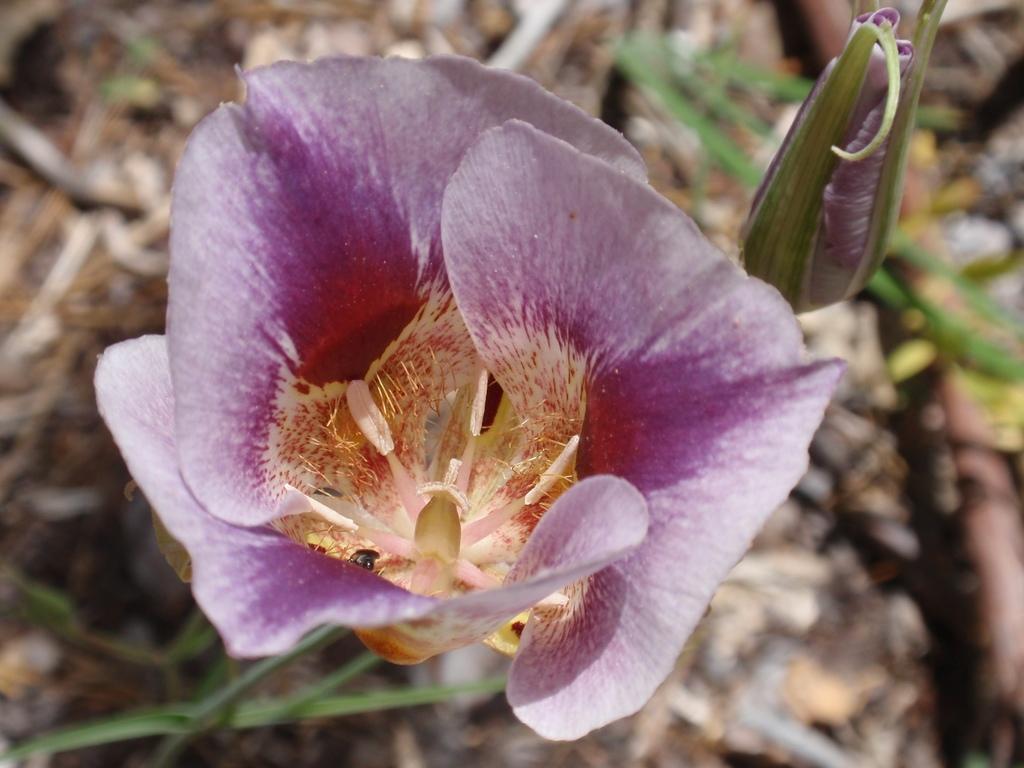Describe this image in one or two sentences. In the center of the image we can see two flowers, which are in pink and yellow color. In the background, we can see one plant, dry leaves and a few other objects. 